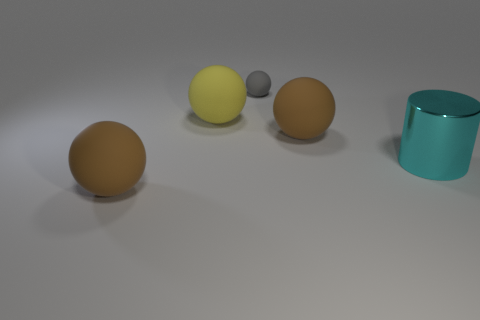Subtract all big yellow balls. How many balls are left? 3 Subtract all purple cubes. How many brown balls are left? 2 Add 3 brown things. How many objects exist? 8 Subtract all yellow balls. How many balls are left? 3 Subtract all yellow spheres. Subtract all yellow cylinders. How many spheres are left? 3 Subtract all tiny spheres. Subtract all gray matte things. How many objects are left? 3 Add 2 tiny things. How many tiny things are left? 3 Add 2 big shiny cylinders. How many big shiny cylinders exist? 3 Subtract 0 blue balls. How many objects are left? 5 Subtract all spheres. How many objects are left? 1 